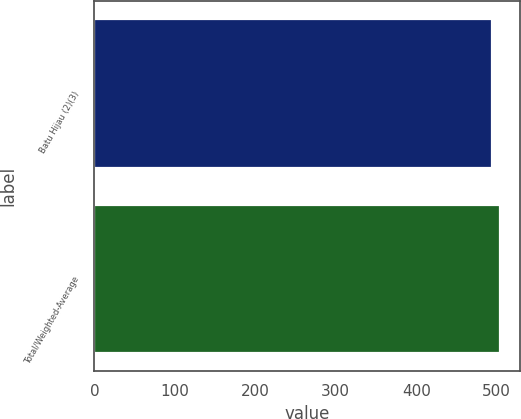<chart> <loc_0><loc_0><loc_500><loc_500><bar_chart><fcel>Batu Hijau (2)(3)<fcel>Total/Weighted-Average<nl><fcel>494<fcel>504<nl></chart> 